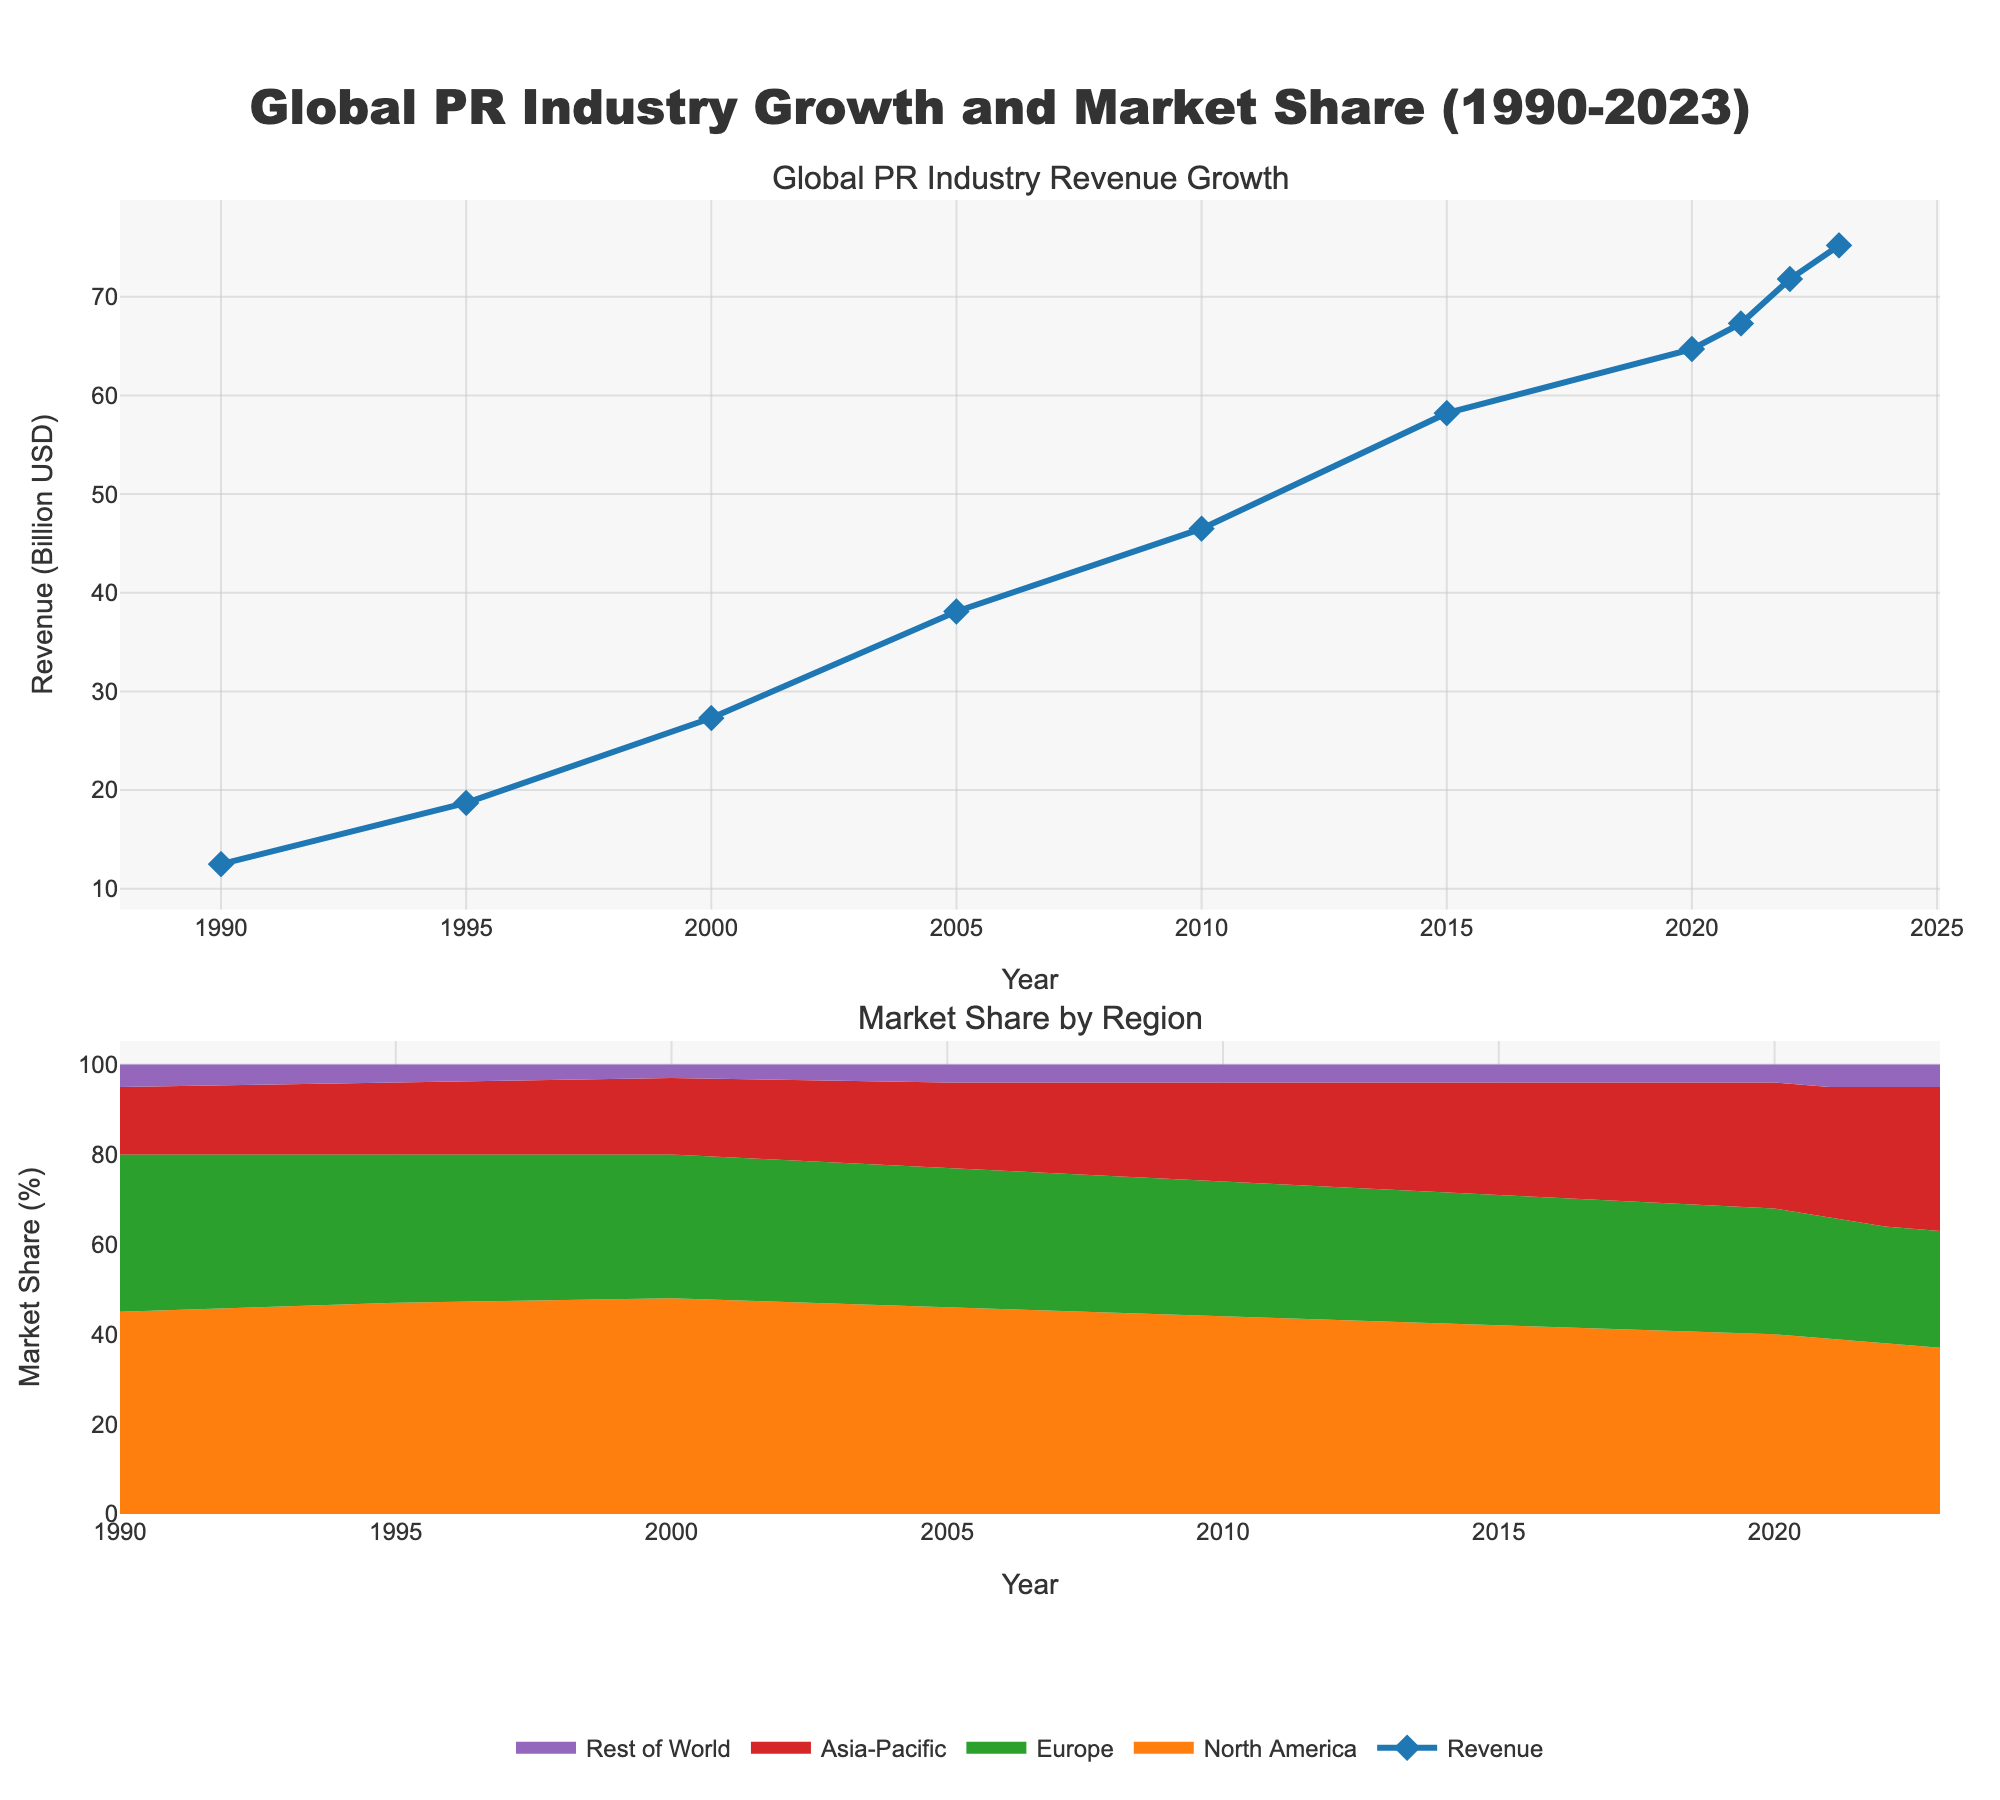What has been the trend in the Global PR Industry Revenue from 1990 to 2023? The revenue has consistently risen over the years without any notable declines, indicating continuous growth. The values increase from $12.5 billion in 1990 to $75.2 billion in 2023.
Answer: Continuous increase Which region had the highest market share in 2023? In 2023, the plot shows that North America had the highest market share when compared to other regions, visible as the largest segment on the area chart.
Answer: North America How did the market share of the Asia-Pacific region change from 1990 to 2023? In 1990, the Asia-Pacific market share was 15%. By 2023, it had increased to 32%, as shown in the plot by the expansion of the highlighted segment for Asia-Pacific.
Answer: Increased from 15% to 32% Compare the market share trends of North America and Europe from 1990 to 2023. North America's market share decreased from 45% in 1990 to 37% in 2023. Europe's market share also decreased from 35% in 1990 to 26% in 2023. Both regions show a declining trend in market share over the years.
Answer: Both declined What is the difference between the Global PR Industry Revenue in 1990 and 2023? The revenue in 1990 was $12.5 billion and in 2023 it was $75.2 billion. The difference is $75.2 billion - $12.5 billion = $62.7 billion.
Answer: $62.7 billion Which year experienced the highest growth in revenue compared to the previous year? By visually comparing the difference in heights of the revenue line year-on-year, 1995 shows a significant jump from 1990, from $12.5 billion to $18.7 billion, indicating the highest growth.
Answer: 1995 What was the approximate average market share of Europe from 1990 to 2023? Europe’s market share varied from 35% in 1990 to 26% in 2023. To approximate the average: (35 + 33 + 32 + 31 + 30 + 29 + 28 + 27 + 26 + 26) / 10 = 29.7%.
Answer: 29.7% Which region shows the most significant increase in market share over the period? Comparing the initial and final values on the area chart, Asia-Pacific shows the most substantial increase from 15% in 1990 to 32% in 2023.
Answer: Asia-Pacific Summarize the overall shift in market share among all regions from 1990 to 2023. North America's share decreased from 45% to 37%, Europe's from 35% to 26%, Asia-Pacific's increased from 15% to 32%, and the Rest of World increased slightly from 5% to 5%.
Answer: North America and Europe declined, Asia-Pacific increased How did revenue change between 2020 and 2023? The revenue in 2020 was $64.7 billion. By 2023, it had increased to $75.2 billion. The difference is $75.2 billion - $64.7 billion = $10.5 billion.
Answer: $10.5 billion 